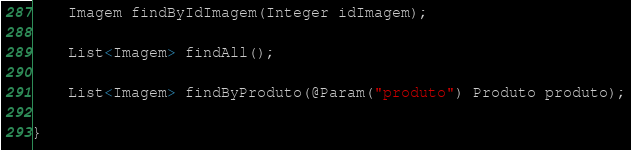Convert code to text. <code><loc_0><loc_0><loc_500><loc_500><_Java_>	Imagem findByIdImagem(Integer idImagem);
	
	List<Imagem> findAll();
	
	List<Imagem> findByProduto(@Param("produto") Produto produto);
	
}
</code> 